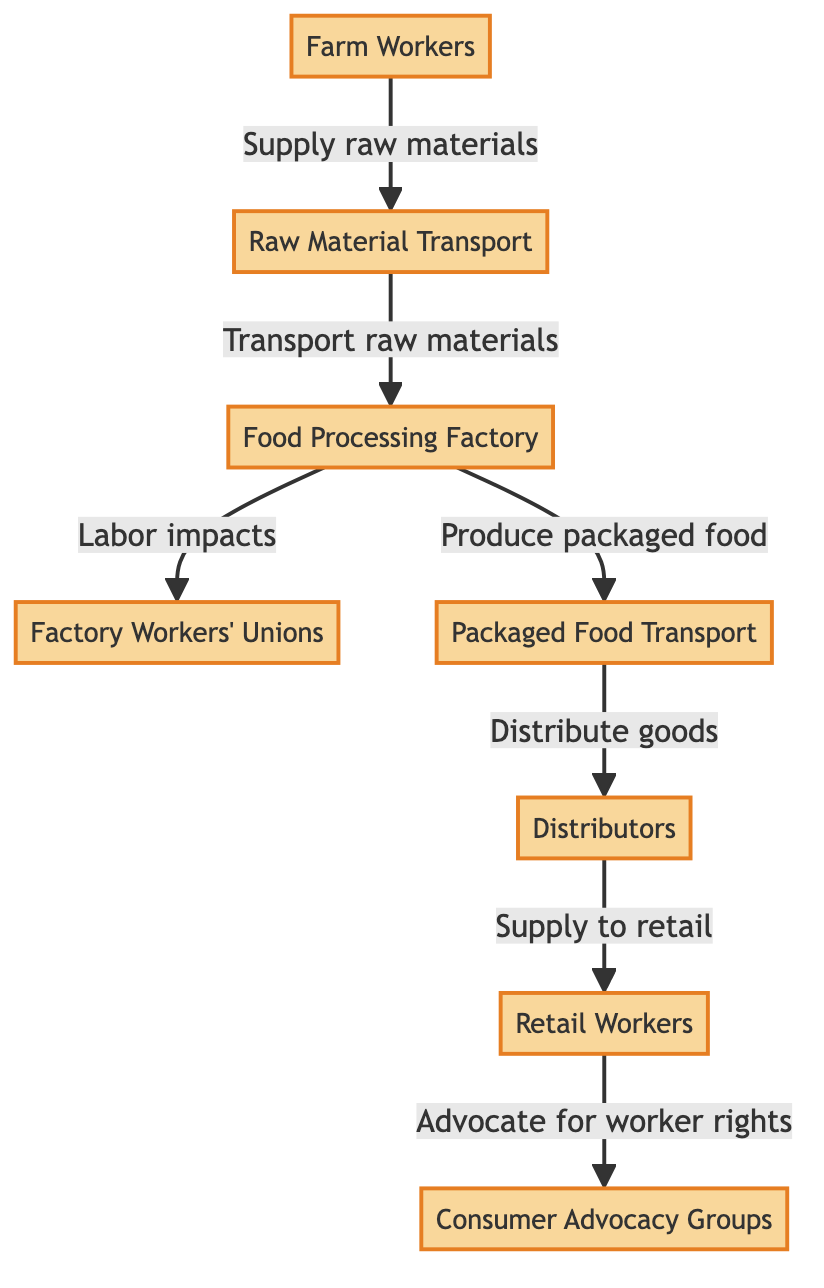What is the first node in the diagram? The first node represents the starting point of the process. It is labeled as "Farm Workers."
Answer: Farm Workers How many nodes are there in total? The diagram features a total of eight nodes, which represent different stages or groups in the food chain.
Answer: 8 Which node is directly connected to "Food Processing Factory"? "Factory Workers' Unions" and "Packaged Food Transport" are both directly connected to "Food Processing Factory," indicating its influence on labor dynamics and production outcomes.
Answer: Factory Workers' Unions, Packaged Food Transport What is the role of "Distributors" in this chain? The "Distributors" node is responsible for distributing goods, illustrating a key role in moving packaged food to the next stage in the supply chain.
Answer: Distribute goods How does "Consumer Advocacy Groups" interact with "Retail Workers"? "Consumer Advocacy Groups" advocate for worker rights, showing their influence on "Retail Workers" who are the final link in the supply chain, thus indirectly affecting worker conditions and wages.
Answer: Advocate for worker rights What is the connection between "Raw Material Transport" and "Food Processing Factory"? "Raw Material Transport" supplies raw materials to the "Food Processing Factory," which is essential for the food production process, linking both nodes directly in the workflow.
Answer: Transport raw materials How do "Factory Workers' Unions" influence the overall food chain? They have a significant role stemming from the "Food Processing Factory," advocating for the rights and conditions of factory workers, which impacts the entire chain, including wages and labor conditions.
Answer: Labor impacts Which nodes support the flow of goods to consumers? The nodes "Packaged Food Transport," "Distributors," and "Retail Workers" collectively support the flow of goods to consumers, illustrating the interconnected structure of product delivery.
Answer: Packaged Food Transport, Distributors, Retail Workers What is the primary function of "Factory Workers' Unions"? The primary function of "Factory Workers' Unions" in this diagram is to represent the labor impacts on workers, advocating for improved wages and conditions within the food processing sector.
Answer: Labor impacts 